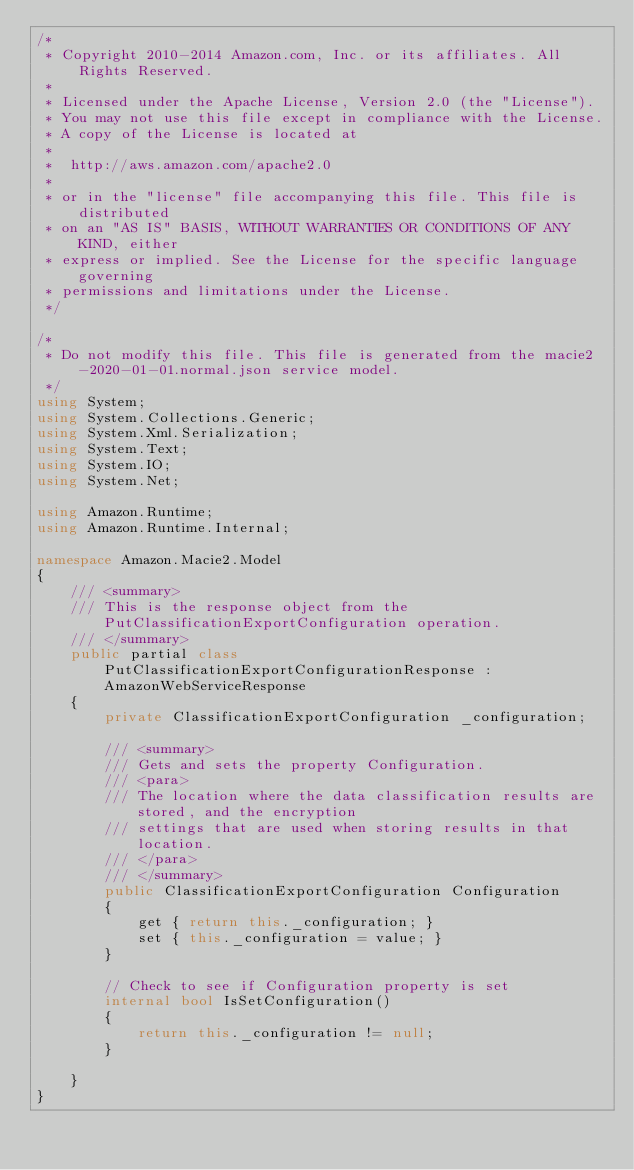<code> <loc_0><loc_0><loc_500><loc_500><_C#_>/*
 * Copyright 2010-2014 Amazon.com, Inc. or its affiliates. All Rights Reserved.
 * 
 * Licensed under the Apache License, Version 2.0 (the "License").
 * You may not use this file except in compliance with the License.
 * A copy of the License is located at
 * 
 *  http://aws.amazon.com/apache2.0
 * 
 * or in the "license" file accompanying this file. This file is distributed
 * on an "AS IS" BASIS, WITHOUT WARRANTIES OR CONDITIONS OF ANY KIND, either
 * express or implied. See the License for the specific language governing
 * permissions and limitations under the License.
 */

/*
 * Do not modify this file. This file is generated from the macie2-2020-01-01.normal.json service model.
 */
using System;
using System.Collections.Generic;
using System.Xml.Serialization;
using System.Text;
using System.IO;
using System.Net;

using Amazon.Runtime;
using Amazon.Runtime.Internal;

namespace Amazon.Macie2.Model
{
    /// <summary>
    /// This is the response object from the PutClassificationExportConfiguration operation.
    /// </summary>
    public partial class PutClassificationExportConfigurationResponse : AmazonWebServiceResponse
    {
        private ClassificationExportConfiguration _configuration;

        /// <summary>
        /// Gets and sets the property Configuration. 
        /// <para>
        /// The location where the data classification results are stored, and the encryption
        /// settings that are used when storing results in that location.
        /// </para>
        /// </summary>
        public ClassificationExportConfiguration Configuration
        {
            get { return this._configuration; }
            set { this._configuration = value; }
        }

        // Check to see if Configuration property is set
        internal bool IsSetConfiguration()
        {
            return this._configuration != null;
        }

    }
}</code> 